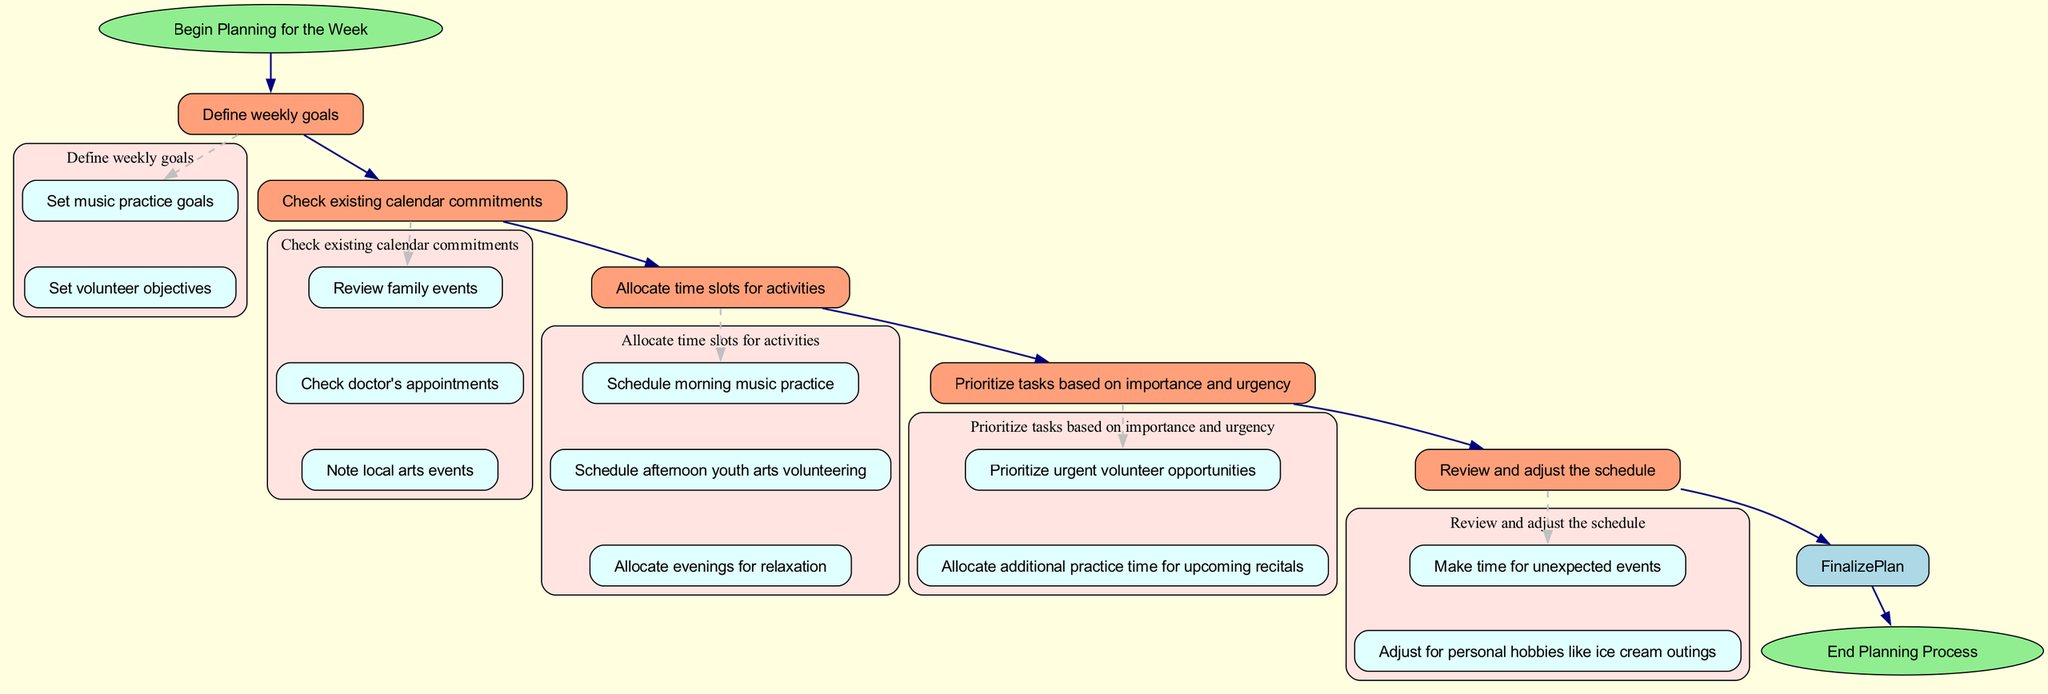What is the first task in the flowchart? The first task indicated in the flowchart is "Begin Planning for the Week," which connects directly from the Start node.
Answer: Begin Planning for the Week How many main tasks are there in the flowchart? The flowchart has five main tasks (Define Goals, Check Calendar, Allocate Time Slots, Prioritize Tasks, Review and Adjust). Each of these tasks is a separate node in the flowchart except for the starting and ending nodes.
Answer: Five Which node connects to Review and Adjust? The node that connects to "Review and Adjust" is "Prioritize Tasks," which is the previous task before it in the flowchart.
Answer: Prioritize Tasks What type of commitments are reviewed in the Check Calendar task? The commitments reviewed in the "Check Calendar" task include family events, doctor's appointments, and local arts events as specified in the subtasks.
Answer: Family events, doctor's appointments, local arts events What action is taken after Finalizing the Plan? After "Finalize the Weekly Schedule," the flowchart directs to the "End Planning Process" node, indicating the conclusion of the planning.
Answer: End Planning Process What is the purpose of the Allocate Time Slots task? The purpose of "Allocate Time Slots" is to schedule specific times for music practice, youth arts volunteering, and relaxation as stated within its subtasks.
Answer: Schedule specific times Which subtask is prioritized in the Prioritize Tasks task? The subtask that is prioritized in the "Prioritize Tasks" task is "Prioritize urgent volunteer opportunities," indicating its significance in the planning process.
Answer: Prioritize urgent volunteer opportunities How does the flowchart suggest handling unexpected events? The flowchart suggests handling unexpected events by making time for them during the "Review and Adjust" process, ensuring flexibility in the weekly schedule.
Answer: Make time for unexpected events What is included in the Allocate Time Slots task regarding evenings? The "Allocate Time Slots" task includes scheduling "evenings for relaxation," indicating designated downtime in the weekly schedule.
Answer: Evenings for relaxation 